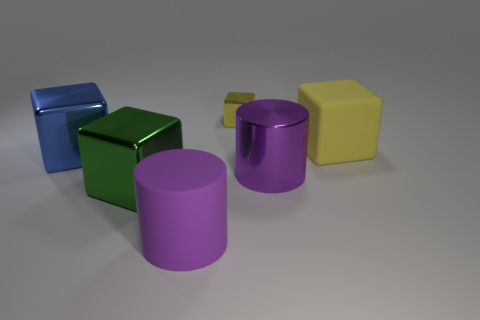Subtract all small cubes. How many cubes are left? 3 Subtract all blue cubes. How many cubes are left? 3 Add 2 large blue cubes. How many objects exist? 8 Subtract all red cubes. Subtract all gray cylinders. How many cubes are left? 4 Subtract all cubes. How many objects are left? 2 Add 3 metal things. How many metal things are left? 7 Add 1 large rubber blocks. How many large rubber blocks exist? 2 Subtract 0 red cylinders. How many objects are left? 6 Subtract all blue blocks. Subtract all tiny yellow cubes. How many objects are left? 4 